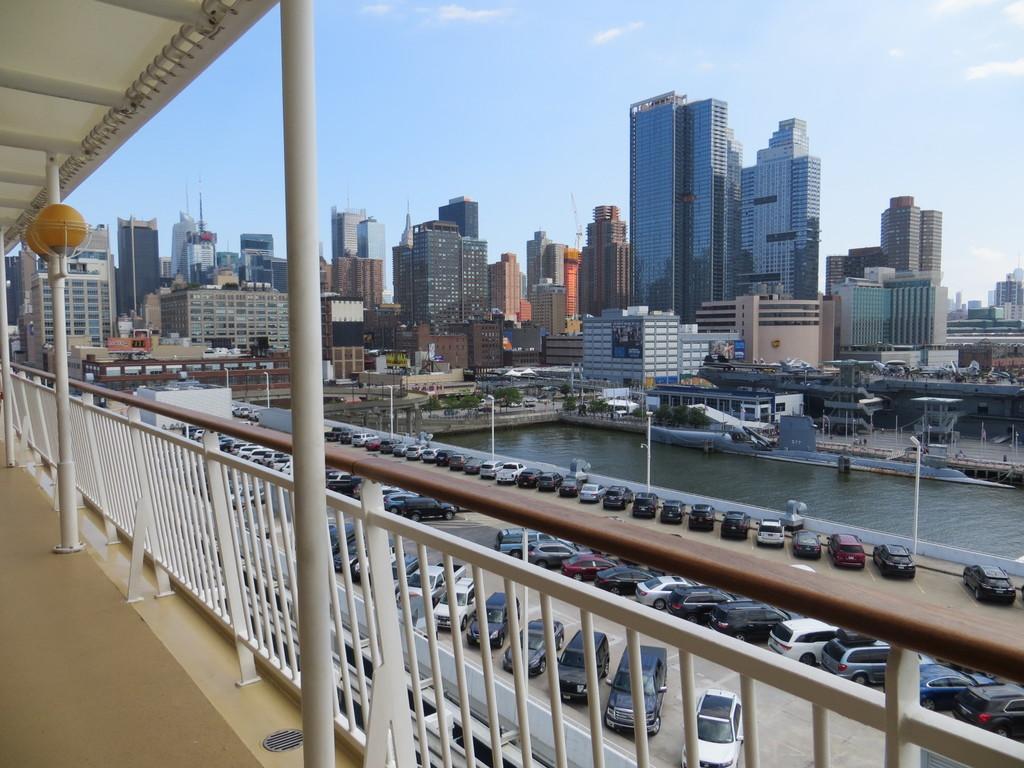How would you summarize this image in a sentence or two? In this image I can see the railing and many vehicles are parked in the parking slot. In the background I can see the poles, water, trees and the buildings. I can also see the clouds and the sky in the back. 